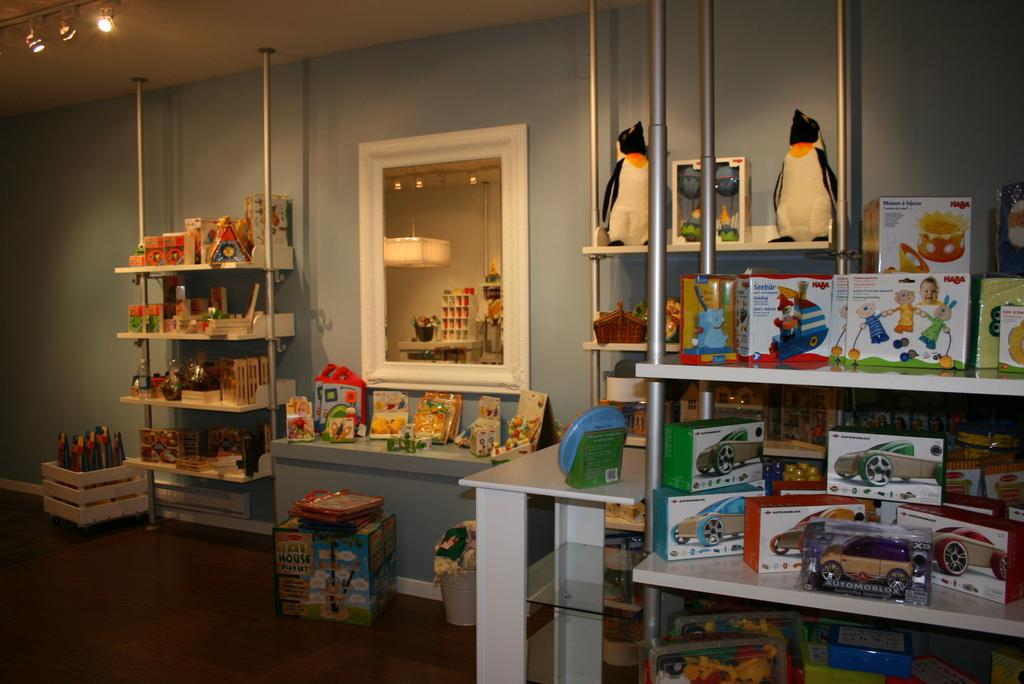<image>
Summarize the visual content of the image. A collection of children's toys including an Automoblox are in a room. 